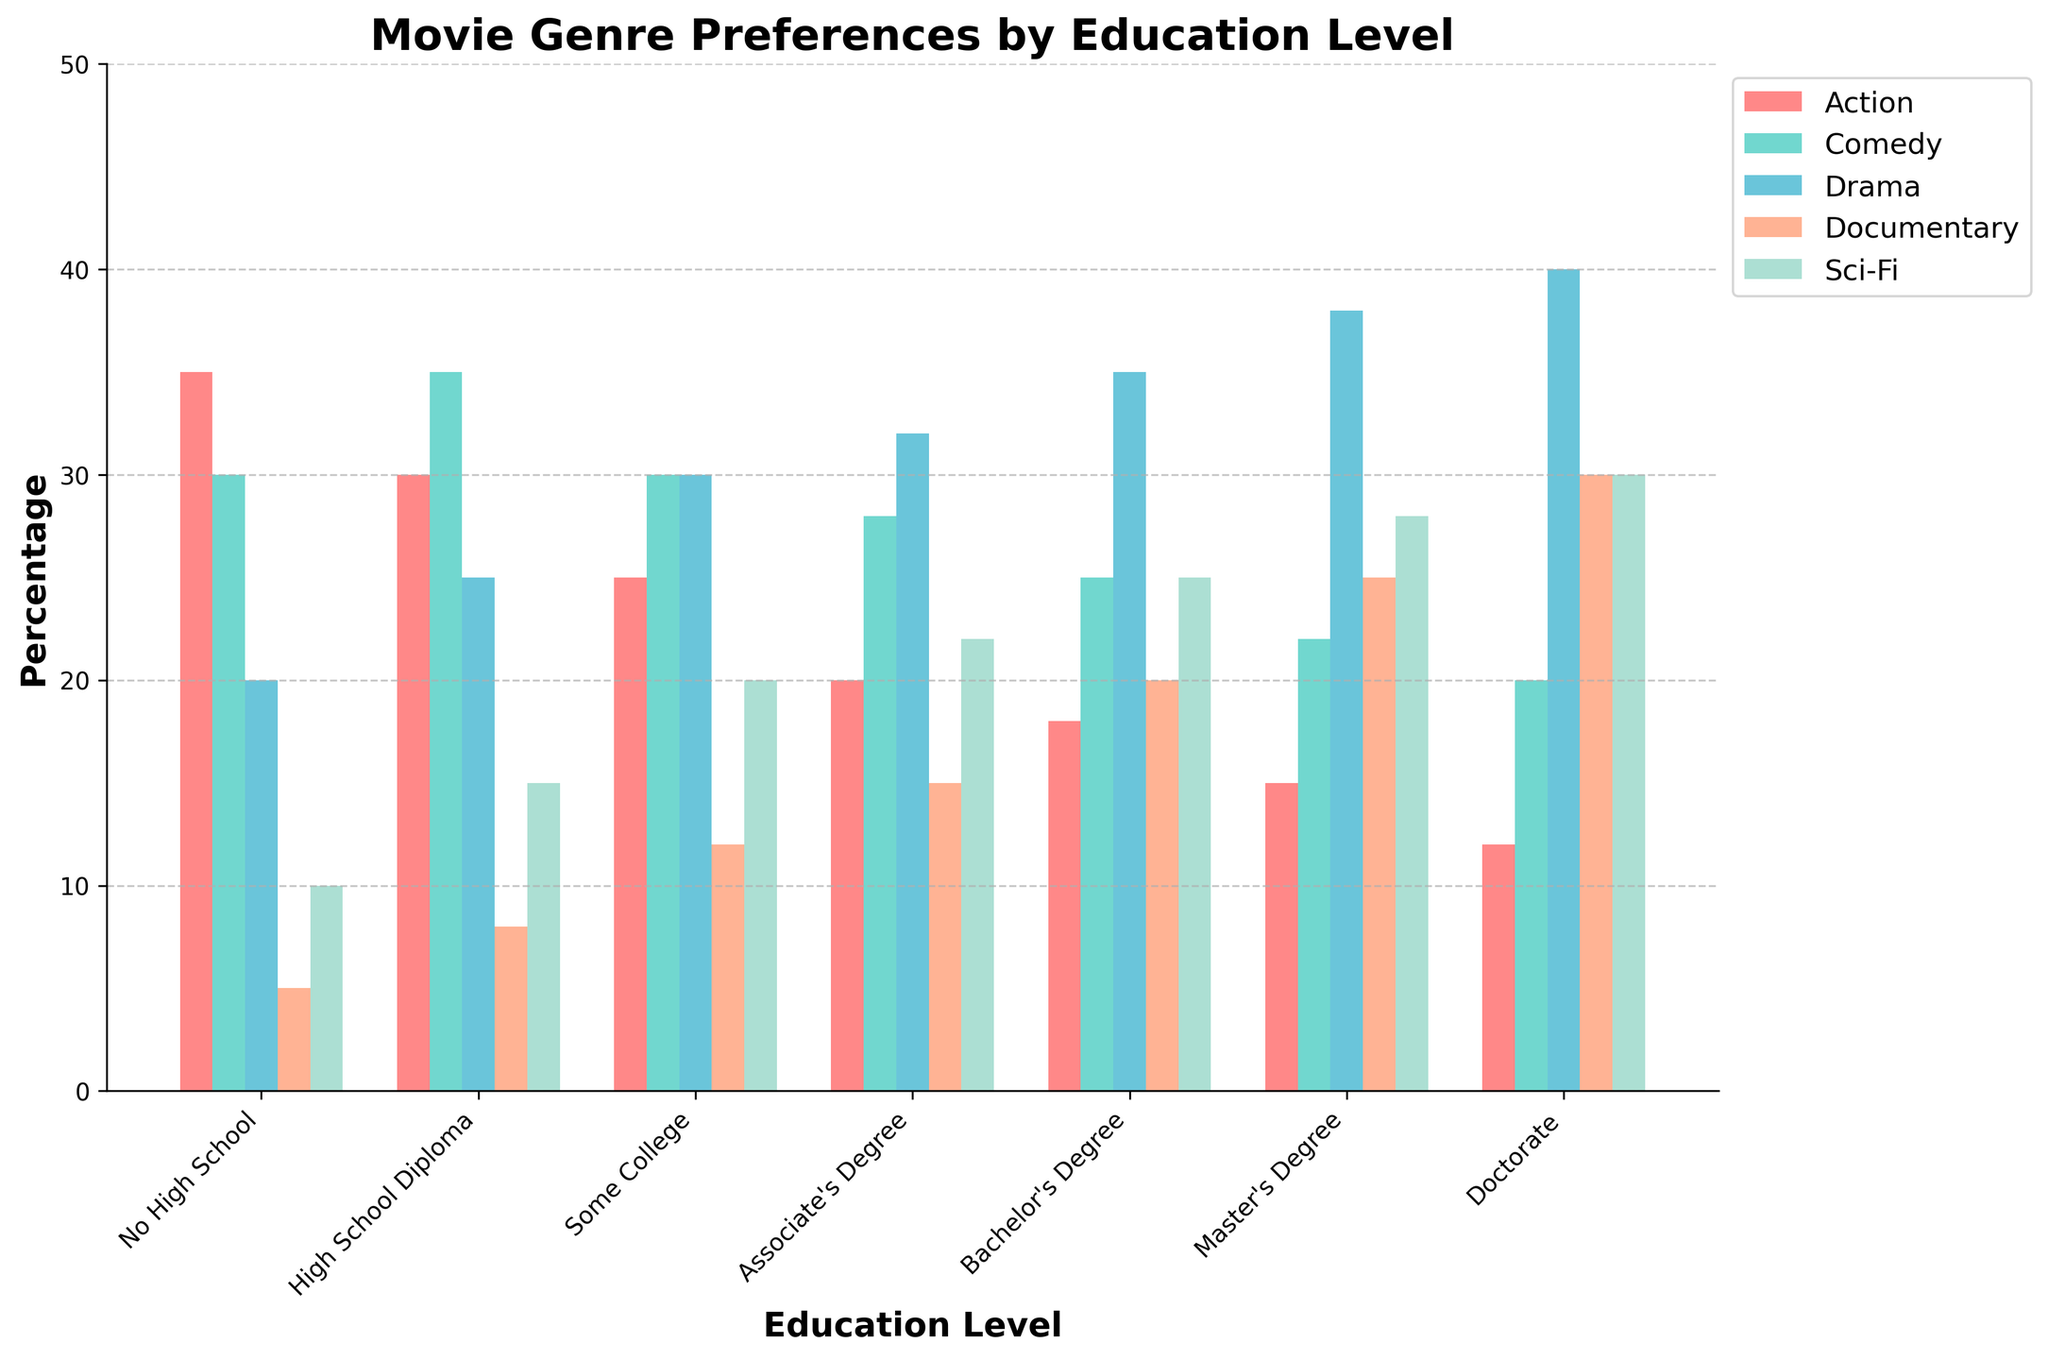What education level has the highest preference for Sci-Fi movies? The Doctorate level shows the highest bar for Sci-Fi movies, indicating 30%.
Answer: Doctorate What is the difference in preference for Documentary movies between people with a Master’s degree and those with no high school education? People with a Master's degree prefer Documentaries 25% and those with no high school education prefer them 5%, the difference is 25% - 5% = 20%.
Answer: 20% Which genre shows an increased preference as the education level increases from No High School to Doctorate? The Drama genre shows progressively taller bars when moving from No High School (20%) to Doctorate (40%).
Answer: Drama For those with Some College education, which genre is preferred more, Comedy or Sci-Fi? The bar for Comedy is taller than the bar for Sci-Fi in the Some College category, indicating higher preference for Comedy (30% vs. 20%).
Answer: Comedy How does the preference for Action movies change with increasing education levels? The preference for Action movies decreases as education levels increase, from 35% at No High School to 12% at Doctorate.
Answer: Decreases Which education level shows the lowest preference for Action movies and which for Comedy movies? The Doctorate level shows the shortest bar for Action (12%), while the Master's degree shows the shortest bar for Comedy (22%).
Answer: Doctorate for Action, Master's Degree for Comedy Comparing preferences between a Bachelor's Degree and an Associate's Degree, which education level has a higher preference for Documentaries? The bar for Documentaries is taller at the Bachelor's Degree level (20%) compared to the Associate's Degree level (15%).
Answer: Bachelor's Degree What is the combined preference for Drama and Sci-Fi movies for those with a Doctorate? The preference for Drama is 40% and for Sci-Fi is 30%, adding these together gives 40% + 30% = 70%.
Answer: 70% What is the visual pattern for Documentary movie preferences as education level increases? The height of the bars representing Documentary preferences generally increases with higher education levels, from 5% at No High School to 30% at Doctorate.
Answer: Increases Do individuals with a High School Diploma prefer Action or Documentary movies more? The bar for Action movies is taller (30%) compared to the bar for Documentaries (8%) for individuals with a High School Diploma.
Answer: Action 